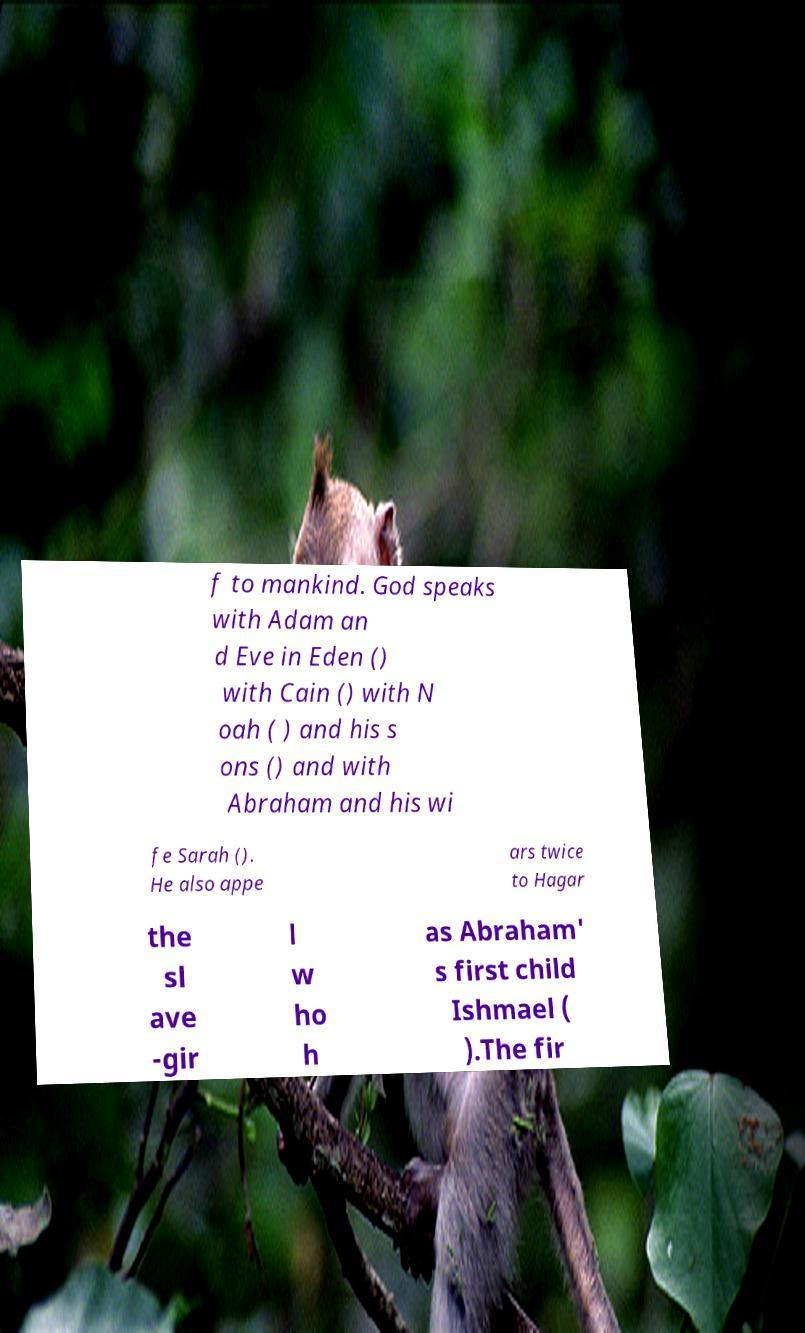For documentation purposes, I need the text within this image transcribed. Could you provide that? f to mankind. God speaks with Adam an d Eve in Eden () with Cain () with N oah ( ) and his s ons () and with Abraham and his wi fe Sarah (). He also appe ars twice to Hagar the sl ave -gir l w ho h as Abraham' s first child Ishmael ( ).The fir 